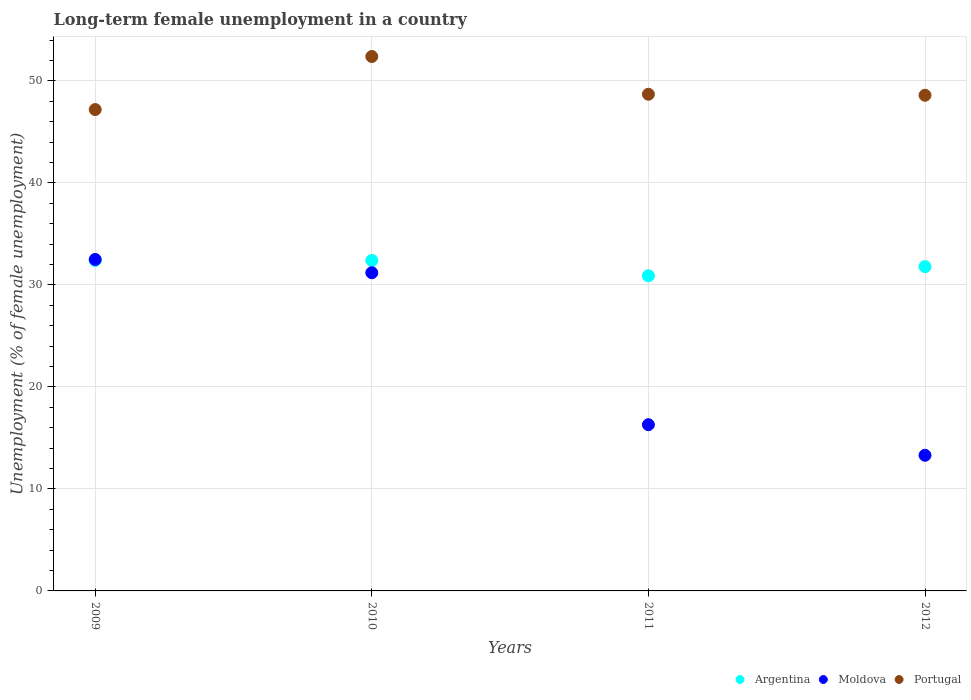Is the number of dotlines equal to the number of legend labels?
Make the answer very short. Yes. What is the percentage of long-term unemployed female population in Argentina in 2009?
Offer a very short reply. 32.4. Across all years, what is the maximum percentage of long-term unemployed female population in Argentina?
Offer a terse response. 32.4. Across all years, what is the minimum percentage of long-term unemployed female population in Portugal?
Provide a succinct answer. 47.2. In which year was the percentage of long-term unemployed female population in Argentina maximum?
Keep it short and to the point. 2009. What is the total percentage of long-term unemployed female population in Portugal in the graph?
Your answer should be very brief. 196.9. What is the difference between the percentage of long-term unemployed female population in Moldova in 2009 and that in 2011?
Give a very brief answer. 16.2. What is the difference between the percentage of long-term unemployed female population in Portugal in 2010 and the percentage of long-term unemployed female population in Argentina in 2012?
Ensure brevity in your answer.  20.6. What is the average percentage of long-term unemployed female population in Argentina per year?
Provide a short and direct response. 31.88. In the year 2012, what is the difference between the percentage of long-term unemployed female population in Moldova and percentage of long-term unemployed female population in Portugal?
Your answer should be very brief. -35.3. In how many years, is the percentage of long-term unemployed female population in Portugal greater than 26 %?
Give a very brief answer. 4. What is the ratio of the percentage of long-term unemployed female population in Portugal in 2009 to that in 2011?
Your answer should be very brief. 0.97. Is the percentage of long-term unemployed female population in Portugal in 2009 less than that in 2011?
Make the answer very short. Yes. Is the difference between the percentage of long-term unemployed female population in Moldova in 2009 and 2010 greater than the difference between the percentage of long-term unemployed female population in Portugal in 2009 and 2010?
Your answer should be compact. Yes. What is the difference between the highest and the second highest percentage of long-term unemployed female population in Moldova?
Give a very brief answer. 1.3. What is the difference between the highest and the lowest percentage of long-term unemployed female population in Portugal?
Offer a very short reply. 5.2. Is the sum of the percentage of long-term unemployed female population in Moldova in 2010 and 2012 greater than the maximum percentage of long-term unemployed female population in Argentina across all years?
Your response must be concise. Yes. Is the percentage of long-term unemployed female population in Argentina strictly less than the percentage of long-term unemployed female population in Moldova over the years?
Your answer should be compact. No. How many dotlines are there?
Offer a very short reply. 3. How many years are there in the graph?
Provide a succinct answer. 4. Does the graph contain any zero values?
Your answer should be compact. No. Does the graph contain grids?
Offer a very short reply. Yes. How many legend labels are there?
Ensure brevity in your answer.  3. What is the title of the graph?
Provide a succinct answer. Long-term female unemployment in a country. What is the label or title of the Y-axis?
Provide a succinct answer. Unemployment (% of female unemployment). What is the Unemployment (% of female unemployment) of Argentina in 2009?
Offer a very short reply. 32.4. What is the Unemployment (% of female unemployment) in Moldova in 2009?
Your response must be concise. 32.5. What is the Unemployment (% of female unemployment) of Portugal in 2009?
Your response must be concise. 47.2. What is the Unemployment (% of female unemployment) of Argentina in 2010?
Make the answer very short. 32.4. What is the Unemployment (% of female unemployment) of Moldova in 2010?
Provide a succinct answer. 31.2. What is the Unemployment (% of female unemployment) in Portugal in 2010?
Provide a short and direct response. 52.4. What is the Unemployment (% of female unemployment) of Argentina in 2011?
Make the answer very short. 30.9. What is the Unemployment (% of female unemployment) in Moldova in 2011?
Offer a terse response. 16.3. What is the Unemployment (% of female unemployment) of Portugal in 2011?
Make the answer very short. 48.7. What is the Unemployment (% of female unemployment) in Argentina in 2012?
Your answer should be very brief. 31.8. What is the Unemployment (% of female unemployment) of Moldova in 2012?
Keep it short and to the point. 13.3. What is the Unemployment (% of female unemployment) of Portugal in 2012?
Offer a terse response. 48.6. Across all years, what is the maximum Unemployment (% of female unemployment) of Argentina?
Offer a very short reply. 32.4. Across all years, what is the maximum Unemployment (% of female unemployment) of Moldova?
Give a very brief answer. 32.5. Across all years, what is the maximum Unemployment (% of female unemployment) in Portugal?
Keep it short and to the point. 52.4. Across all years, what is the minimum Unemployment (% of female unemployment) in Argentina?
Your answer should be compact. 30.9. Across all years, what is the minimum Unemployment (% of female unemployment) in Moldova?
Offer a terse response. 13.3. Across all years, what is the minimum Unemployment (% of female unemployment) in Portugal?
Your answer should be compact. 47.2. What is the total Unemployment (% of female unemployment) in Argentina in the graph?
Give a very brief answer. 127.5. What is the total Unemployment (% of female unemployment) of Moldova in the graph?
Your response must be concise. 93.3. What is the total Unemployment (% of female unemployment) in Portugal in the graph?
Your answer should be very brief. 196.9. What is the difference between the Unemployment (% of female unemployment) of Moldova in 2009 and that in 2011?
Offer a terse response. 16.2. What is the difference between the Unemployment (% of female unemployment) in Portugal in 2009 and that in 2011?
Your response must be concise. -1.5. What is the difference between the Unemployment (% of female unemployment) in Argentina in 2009 and that in 2012?
Keep it short and to the point. 0.6. What is the difference between the Unemployment (% of female unemployment) of Portugal in 2009 and that in 2012?
Give a very brief answer. -1.4. What is the difference between the Unemployment (% of female unemployment) of Argentina in 2009 and the Unemployment (% of female unemployment) of Moldova in 2010?
Offer a terse response. 1.2. What is the difference between the Unemployment (% of female unemployment) in Moldova in 2009 and the Unemployment (% of female unemployment) in Portugal in 2010?
Provide a short and direct response. -19.9. What is the difference between the Unemployment (% of female unemployment) in Argentina in 2009 and the Unemployment (% of female unemployment) in Moldova in 2011?
Keep it short and to the point. 16.1. What is the difference between the Unemployment (% of female unemployment) in Argentina in 2009 and the Unemployment (% of female unemployment) in Portugal in 2011?
Provide a succinct answer. -16.3. What is the difference between the Unemployment (% of female unemployment) of Moldova in 2009 and the Unemployment (% of female unemployment) of Portugal in 2011?
Your answer should be very brief. -16.2. What is the difference between the Unemployment (% of female unemployment) of Argentina in 2009 and the Unemployment (% of female unemployment) of Portugal in 2012?
Ensure brevity in your answer.  -16.2. What is the difference between the Unemployment (% of female unemployment) in Moldova in 2009 and the Unemployment (% of female unemployment) in Portugal in 2012?
Provide a succinct answer. -16.1. What is the difference between the Unemployment (% of female unemployment) in Argentina in 2010 and the Unemployment (% of female unemployment) in Portugal in 2011?
Provide a succinct answer. -16.3. What is the difference between the Unemployment (% of female unemployment) of Moldova in 2010 and the Unemployment (% of female unemployment) of Portugal in 2011?
Keep it short and to the point. -17.5. What is the difference between the Unemployment (% of female unemployment) of Argentina in 2010 and the Unemployment (% of female unemployment) of Portugal in 2012?
Offer a very short reply. -16.2. What is the difference between the Unemployment (% of female unemployment) of Moldova in 2010 and the Unemployment (% of female unemployment) of Portugal in 2012?
Make the answer very short. -17.4. What is the difference between the Unemployment (% of female unemployment) in Argentina in 2011 and the Unemployment (% of female unemployment) in Moldova in 2012?
Your answer should be very brief. 17.6. What is the difference between the Unemployment (% of female unemployment) of Argentina in 2011 and the Unemployment (% of female unemployment) of Portugal in 2012?
Offer a very short reply. -17.7. What is the difference between the Unemployment (% of female unemployment) in Moldova in 2011 and the Unemployment (% of female unemployment) in Portugal in 2012?
Make the answer very short. -32.3. What is the average Unemployment (% of female unemployment) of Argentina per year?
Your answer should be very brief. 31.88. What is the average Unemployment (% of female unemployment) of Moldova per year?
Offer a very short reply. 23.32. What is the average Unemployment (% of female unemployment) in Portugal per year?
Keep it short and to the point. 49.23. In the year 2009, what is the difference between the Unemployment (% of female unemployment) of Argentina and Unemployment (% of female unemployment) of Portugal?
Your response must be concise. -14.8. In the year 2009, what is the difference between the Unemployment (% of female unemployment) of Moldova and Unemployment (% of female unemployment) of Portugal?
Your answer should be very brief. -14.7. In the year 2010, what is the difference between the Unemployment (% of female unemployment) of Moldova and Unemployment (% of female unemployment) of Portugal?
Your response must be concise. -21.2. In the year 2011, what is the difference between the Unemployment (% of female unemployment) in Argentina and Unemployment (% of female unemployment) in Moldova?
Provide a succinct answer. 14.6. In the year 2011, what is the difference between the Unemployment (% of female unemployment) of Argentina and Unemployment (% of female unemployment) of Portugal?
Offer a very short reply. -17.8. In the year 2011, what is the difference between the Unemployment (% of female unemployment) of Moldova and Unemployment (% of female unemployment) of Portugal?
Make the answer very short. -32.4. In the year 2012, what is the difference between the Unemployment (% of female unemployment) of Argentina and Unemployment (% of female unemployment) of Portugal?
Offer a very short reply. -16.8. In the year 2012, what is the difference between the Unemployment (% of female unemployment) of Moldova and Unemployment (% of female unemployment) of Portugal?
Provide a succinct answer. -35.3. What is the ratio of the Unemployment (% of female unemployment) of Moldova in 2009 to that in 2010?
Your answer should be very brief. 1.04. What is the ratio of the Unemployment (% of female unemployment) of Portugal in 2009 to that in 2010?
Keep it short and to the point. 0.9. What is the ratio of the Unemployment (% of female unemployment) of Argentina in 2009 to that in 2011?
Your answer should be compact. 1.05. What is the ratio of the Unemployment (% of female unemployment) of Moldova in 2009 to that in 2011?
Your response must be concise. 1.99. What is the ratio of the Unemployment (% of female unemployment) in Portugal in 2009 to that in 2011?
Keep it short and to the point. 0.97. What is the ratio of the Unemployment (% of female unemployment) of Argentina in 2009 to that in 2012?
Offer a terse response. 1.02. What is the ratio of the Unemployment (% of female unemployment) of Moldova in 2009 to that in 2012?
Your response must be concise. 2.44. What is the ratio of the Unemployment (% of female unemployment) in Portugal in 2009 to that in 2012?
Offer a very short reply. 0.97. What is the ratio of the Unemployment (% of female unemployment) of Argentina in 2010 to that in 2011?
Your answer should be very brief. 1.05. What is the ratio of the Unemployment (% of female unemployment) in Moldova in 2010 to that in 2011?
Provide a succinct answer. 1.91. What is the ratio of the Unemployment (% of female unemployment) in Portugal in 2010 to that in 2011?
Ensure brevity in your answer.  1.08. What is the ratio of the Unemployment (% of female unemployment) of Argentina in 2010 to that in 2012?
Make the answer very short. 1.02. What is the ratio of the Unemployment (% of female unemployment) of Moldova in 2010 to that in 2012?
Your answer should be compact. 2.35. What is the ratio of the Unemployment (% of female unemployment) in Portugal in 2010 to that in 2012?
Ensure brevity in your answer.  1.08. What is the ratio of the Unemployment (% of female unemployment) of Argentina in 2011 to that in 2012?
Your response must be concise. 0.97. What is the ratio of the Unemployment (% of female unemployment) in Moldova in 2011 to that in 2012?
Your answer should be very brief. 1.23. What is the ratio of the Unemployment (% of female unemployment) in Portugal in 2011 to that in 2012?
Ensure brevity in your answer.  1. What is the difference between the highest and the second highest Unemployment (% of female unemployment) of Argentina?
Provide a short and direct response. 0. What is the difference between the highest and the lowest Unemployment (% of female unemployment) in Argentina?
Offer a very short reply. 1.5. What is the difference between the highest and the lowest Unemployment (% of female unemployment) of Moldova?
Keep it short and to the point. 19.2. 